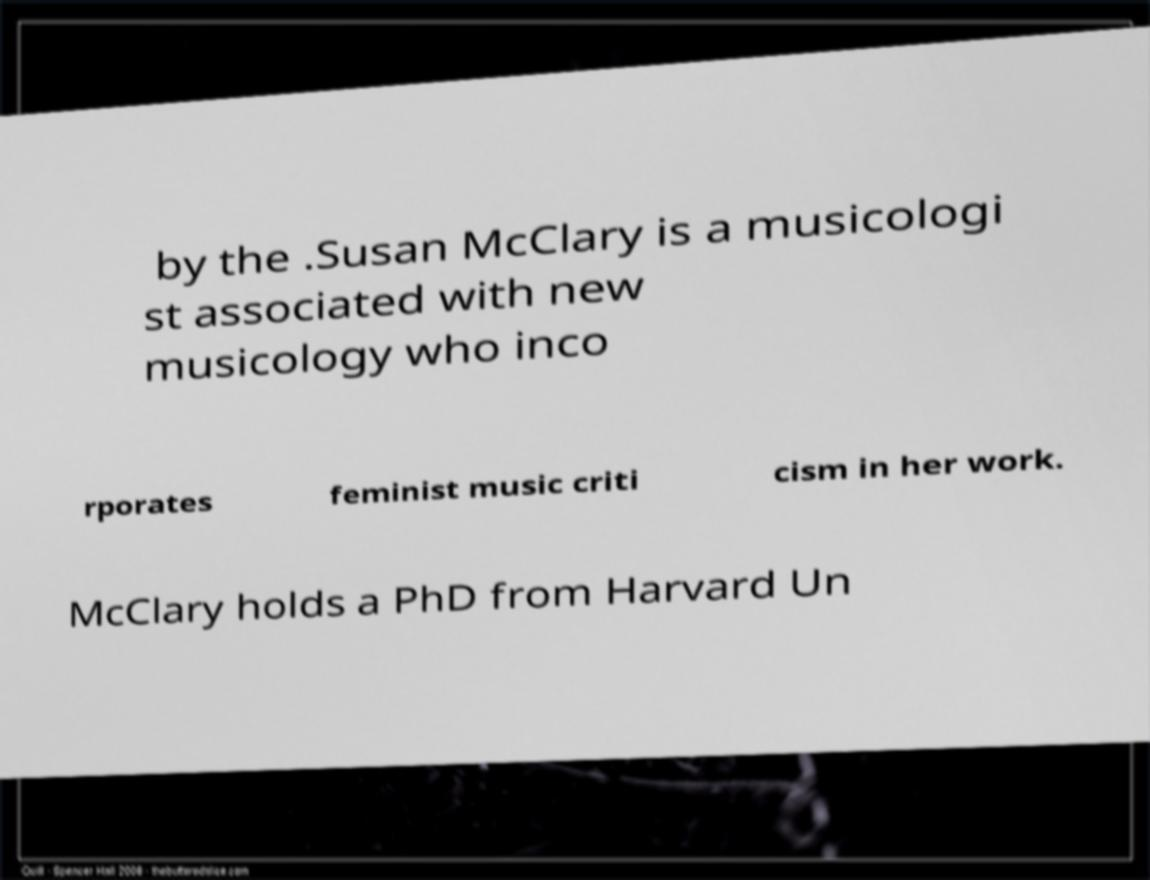Could you assist in decoding the text presented in this image and type it out clearly? by the .Susan McClary is a musicologi st associated with new musicology who inco rporates feminist music criti cism in her work. McClary holds a PhD from Harvard Un 